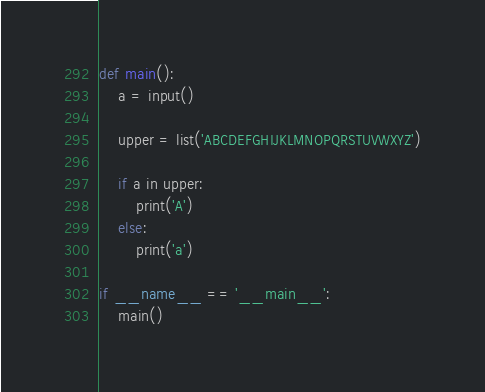Convert code to text. <code><loc_0><loc_0><loc_500><loc_500><_Python_>def main():
    a = input()

    upper = list('ABCDEFGHIJKLMNOPQRSTUVWXYZ')

    if a in upper:
        print('A')
    else:
        print('a')

if __name__ == '__main__':
    main()</code> 